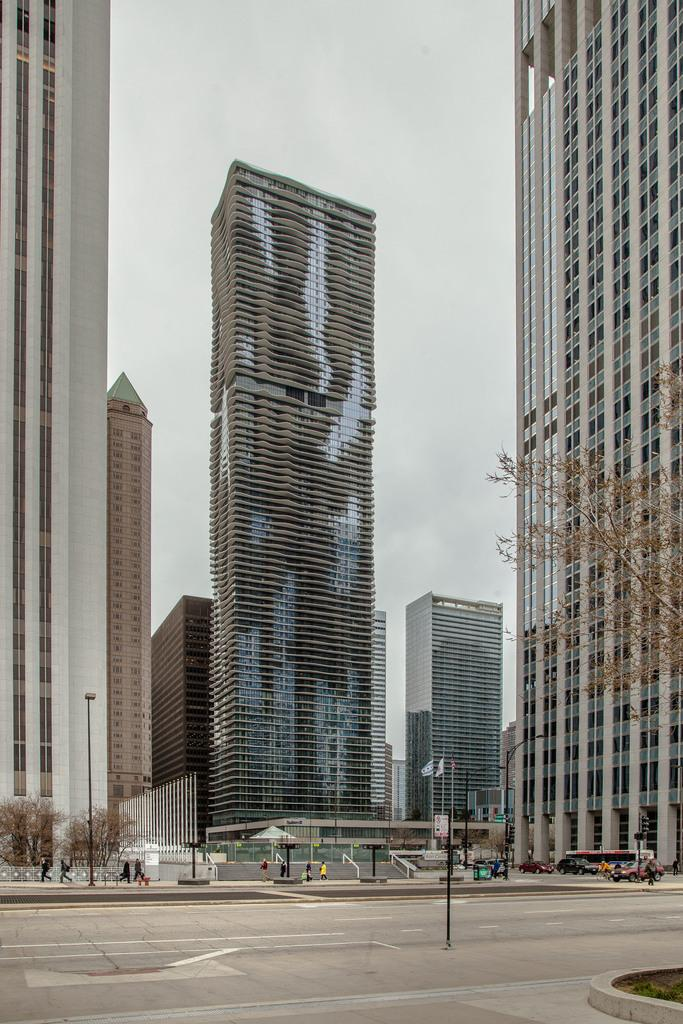What type of structures can be seen in the image? There are buildings in the image. What natural elements are present in the image? Trees are present in the image. Are there any living beings visible in the image? Yes, there are people in the image. What symbolic objects can be seen in the image? Flags are visible in the image. What is the tall, vertical object in the image? There is a pole in the image. What type of transportation is present in the image? Vehicles are on the road in the image. Can you recall a specific memory that the people in the image are discussing? There is no information provided about the people's conversation or memories in the image. 